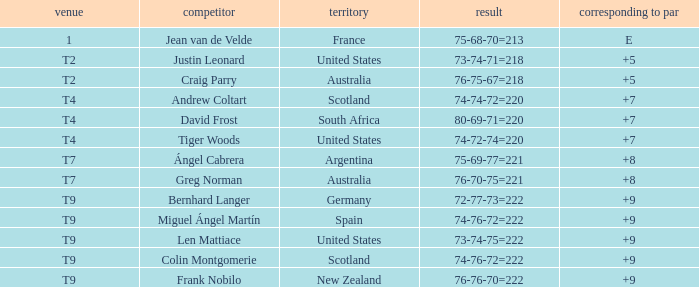What is the To Par score for the player from South Africa? 7.0. 